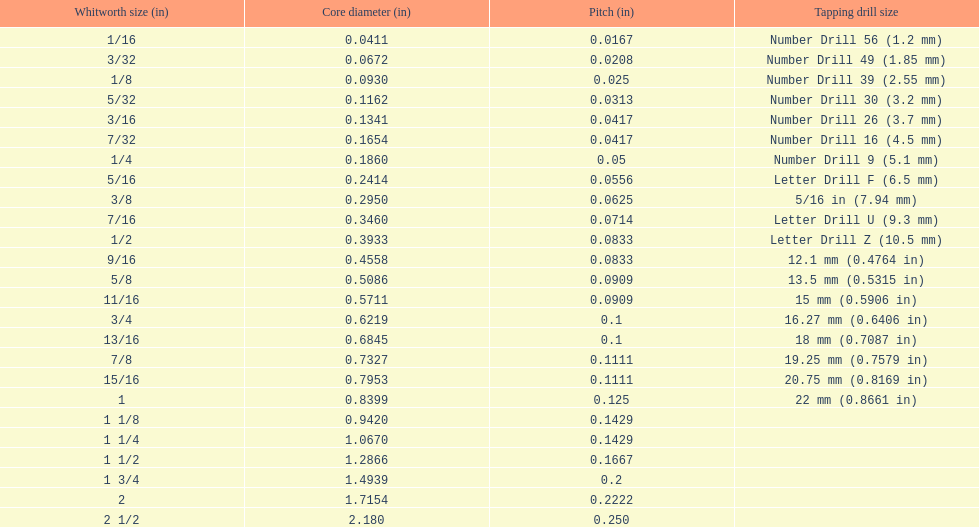What are the standard whitworth sizes in inches? 1/16, 3/32, 1/8, 5/32, 3/16, 7/32, 1/4, 5/16, 3/8, 7/16, 1/2, 9/16, 5/8, 11/16, 3/4, 13/16, 7/8, 15/16, 1, 1 1/8, 1 1/4, 1 1/2, 1 3/4, 2, 2 1/2. How many threads per inch does the 3/16 size have? 24. Which size (in inches) has the same number of threads? 7/32. 